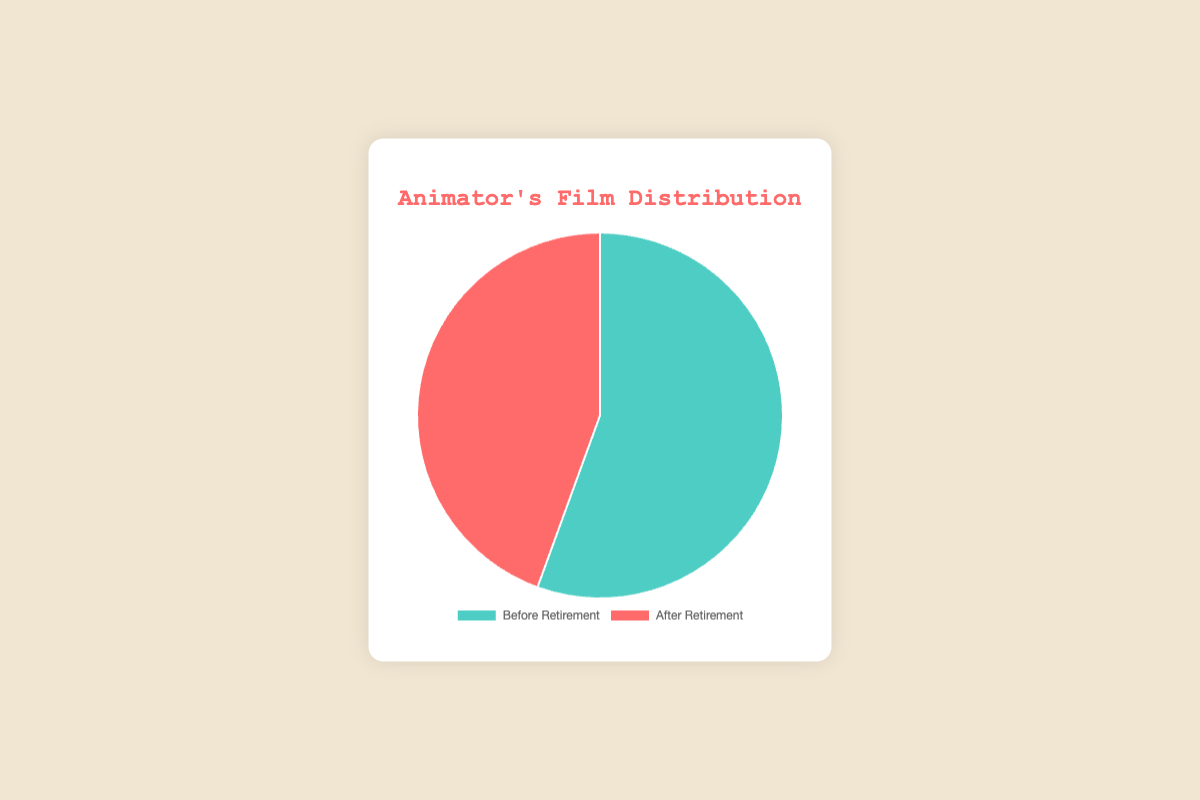What is the proportion of films made by the animator before retirement compared to the total number of films? The chart shows that the animator made 5 films before retirement. To find the proportion, add the films made before and after retirement (5+4=9). The proportion is 5/9 or approximately 55.56%.
Answer: 55.56% How many more films were made by the animator before retirement than after retirement? The chart indicates the animator made 5 films before retirement and 4 after. The difference between these numbers is 5 - 4 = 1.
Answer: 1 What color represents the films made before retirement? According to the legend in the pie chart, the films made before retirement are represented by the turquoise slice.
Answer: Turquoise What is the ratio of films made before retirement to those made after retirement? The pie chart shows that the animator made 5 films before retirement and 4 films after retirement. The ratio is 5:4.
Answer: 5:4 If the animator had made one more film after retirement, what percentage of the total films would that be? First, calculate the new total number of films: 5 (before retirement) + 5 (after retirement, including one more) = 10. The percentage of films made after retirement would be (5/10) * 100 = 50%.
Answer: 50% Which period had a higher number of films made, before or after retirement? The chart shows that 5 films were made before retirement and 4 films after. Therefore, more films were made before retirement.
Answer: Before retirement What percentage of the films were made after retirement? The chart shows 4 films were made after retirement. With a total of 9 films (5 before and 4 after), the percentage is (4/9) * 100 ≈ 44.44%.
Answer: 44.44% How many more films need to be made after retirement to equal the number made before retirement? The animator made 5 films before retirement and 4 after. To equalize, 1 more film would need to be made after retirement (5 - 4 = 1).
Answer: 1 Which color in the chart represents the films made after retirement? The pie chart legend shows that the slice representing films made after retirement is colored red.
Answer: Red 